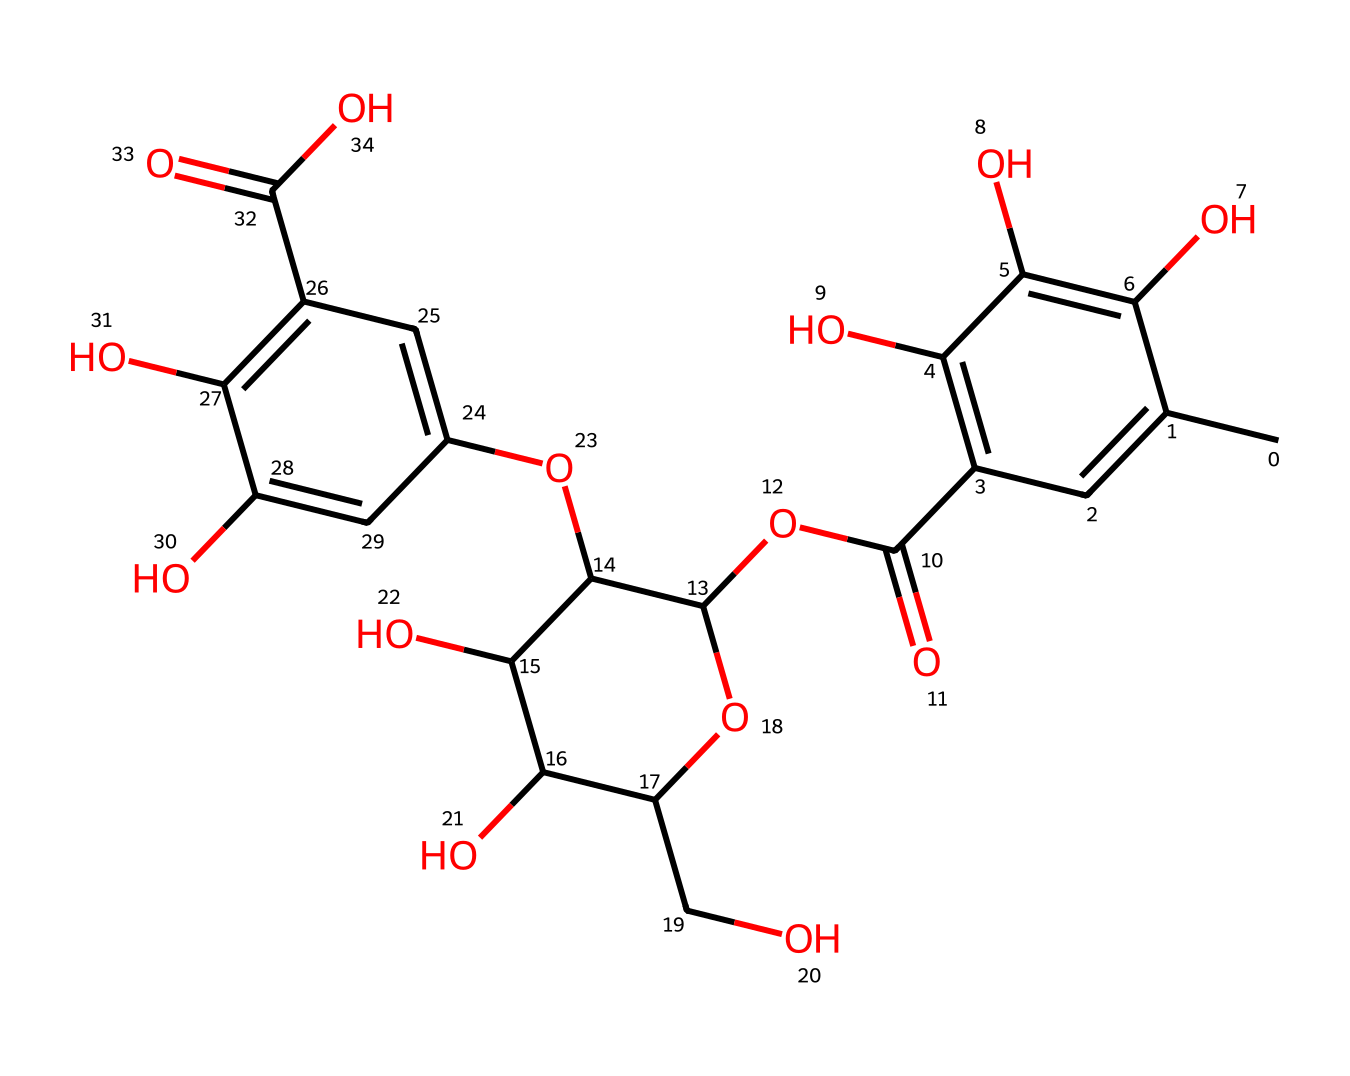what is the molecular formula of this chemical? To determine the molecular formula, count the number of each type of atom present in the SMILES structure. The molecule has 21 carbon (C) atoms, 22 hydrogen (H) atoms, and 10 oxygen (O) atoms. Therefore, the molecular formula is C21H22O10.
Answer: C21H22O10 how many rings are present in this structure? By closely examining the structure, we can see that there are three fused rings in this chemical, which are characteristic of flavonoid compounds. Hence, the total count of rings is three.
Answer: three what functional groups are present in this molecule? Analyzing the structure reveals the presence of multiple hydroxyl (-OH) groups, a carboxylic acid (-COOH) group, and an ester (-COO-) group. These groups contribute to the chemical’s properties and behavior during dyeing.
Answer: hydroxyl, carboxylic acid, ester how does the presence of hydroxyl groups affect dyeing capabilities? The hydroxyl groups enhance the solubility and reactivity of the tannins in dyeing processes, allowing for better interaction with textile fibers. The numerous -OH groups improve the ability to bond with the fabric, thus enhancing color retention and intensity.
Answer: enhances solubility what type of non-Newtonian fluid behavior might this chemical exhibit when used in dyeing? This chemical may exhibit shear-thinning behavior, which means its viscosity decreases under shear stress, allowing it to spread more easily on textile surfaces during the dyeing process. This property is beneficial for an even dye application.
Answer: shear-thinning what is the significance of the ester functional group in this dye? The ester functionality can facilitate the attachment of dye molecules to fibers, which can improve the durability of the dye on textiles, making the colors more permanent and resistant to washing.
Answer: improves durability how might the chemical structure influence color variability in natural dyes? The diverse arrangement of functional groups and aromatic rings contributes to the stability and variety of color shades that can be achieved. The variations in the molecular structure allow for a wide range of interactions with other dyes, leading to different color outcomes.
Answer: influences color variability 